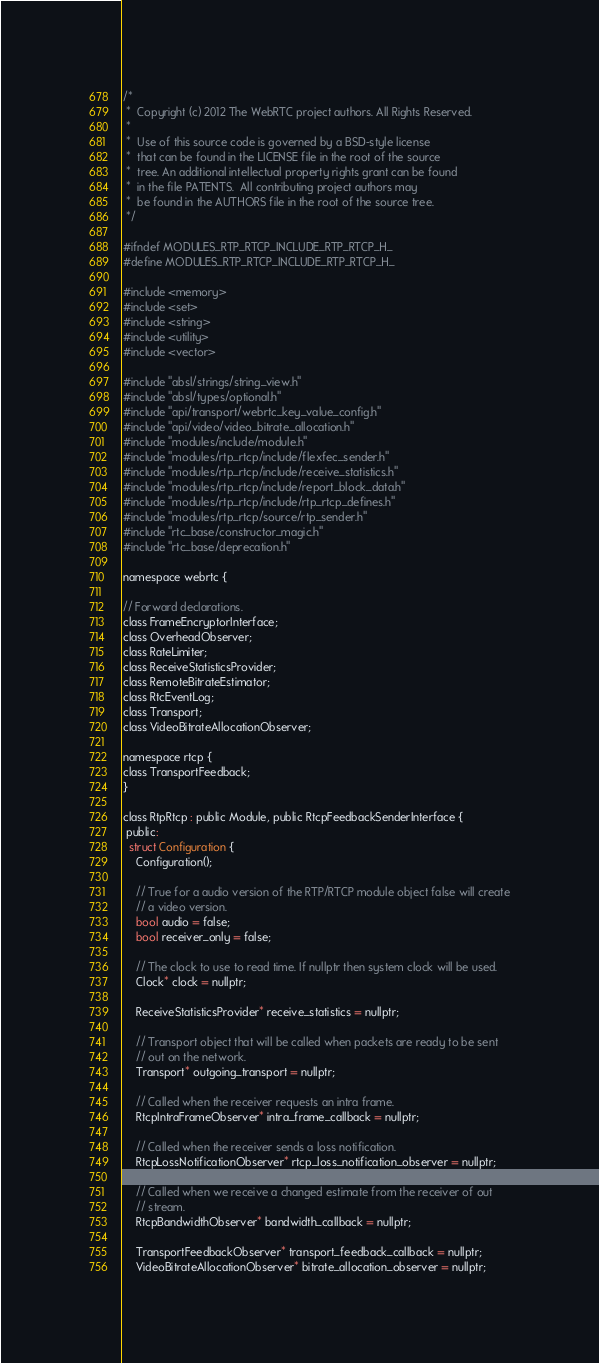<code> <loc_0><loc_0><loc_500><loc_500><_C_>/*
 *  Copyright (c) 2012 The WebRTC project authors. All Rights Reserved.
 *
 *  Use of this source code is governed by a BSD-style license
 *  that can be found in the LICENSE file in the root of the source
 *  tree. An additional intellectual property rights grant can be found
 *  in the file PATENTS.  All contributing project authors may
 *  be found in the AUTHORS file in the root of the source tree.
 */

#ifndef MODULES_RTP_RTCP_INCLUDE_RTP_RTCP_H_
#define MODULES_RTP_RTCP_INCLUDE_RTP_RTCP_H_

#include <memory>
#include <set>
#include <string>
#include <utility>
#include <vector>

#include "absl/strings/string_view.h"
#include "absl/types/optional.h"
#include "api/transport/webrtc_key_value_config.h"
#include "api/video/video_bitrate_allocation.h"
#include "modules/include/module.h"
#include "modules/rtp_rtcp/include/flexfec_sender.h"
#include "modules/rtp_rtcp/include/receive_statistics.h"
#include "modules/rtp_rtcp/include/report_block_data.h"
#include "modules/rtp_rtcp/include/rtp_rtcp_defines.h"
#include "modules/rtp_rtcp/source/rtp_sender.h"
#include "rtc_base/constructor_magic.h"
#include "rtc_base/deprecation.h"

namespace webrtc {

// Forward declarations.
class FrameEncryptorInterface;
class OverheadObserver;
class RateLimiter;
class ReceiveStatisticsProvider;
class RemoteBitrateEstimator;
class RtcEventLog;
class Transport;
class VideoBitrateAllocationObserver;

namespace rtcp {
class TransportFeedback;
}

class RtpRtcp : public Module, public RtcpFeedbackSenderInterface {
 public:
  struct Configuration {
    Configuration();

    // True for a audio version of the RTP/RTCP module object false will create
    // a video version.
    bool audio = false;
    bool receiver_only = false;

    // The clock to use to read time. If nullptr then system clock will be used.
    Clock* clock = nullptr;

    ReceiveStatisticsProvider* receive_statistics = nullptr;

    // Transport object that will be called when packets are ready to be sent
    // out on the network.
    Transport* outgoing_transport = nullptr;

    // Called when the receiver requests an intra frame.
    RtcpIntraFrameObserver* intra_frame_callback = nullptr;

    // Called when the receiver sends a loss notification.
    RtcpLossNotificationObserver* rtcp_loss_notification_observer = nullptr;

    // Called when we receive a changed estimate from the receiver of out
    // stream.
    RtcpBandwidthObserver* bandwidth_callback = nullptr;

    TransportFeedbackObserver* transport_feedback_callback = nullptr;
    VideoBitrateAllocationObserver* bitrate_allocation_observer = nullptr;</code> 